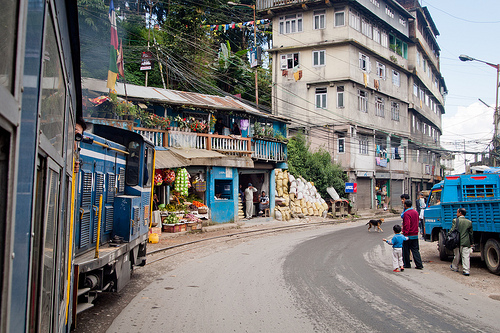<image>
Is the truck to the left of the man? No. The truck is not to the left of the man. From this viewpoint, they have a different horizontal relationship. 